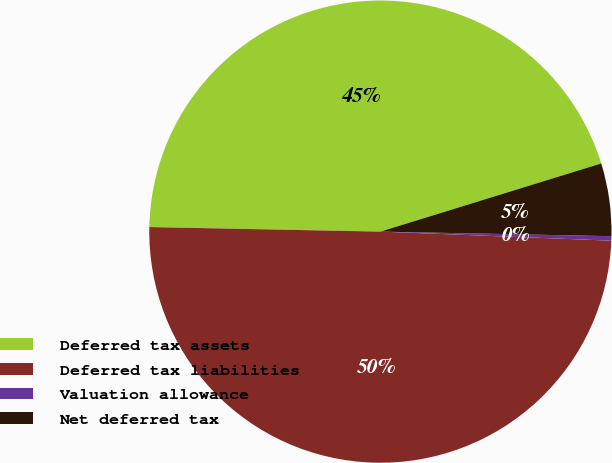<chart> <loc_0><loc_0><loc_500><loc_500><pie_chart><fcel>Deferred tax assets<fcel>Deferred tax liabilities<fcel>Valuation allowance<fcel>Net deferred tax<nl><fcel>44.92%<fcel>49.69%<fcel>0.31%<fcel>5.08%<nl></chart> 